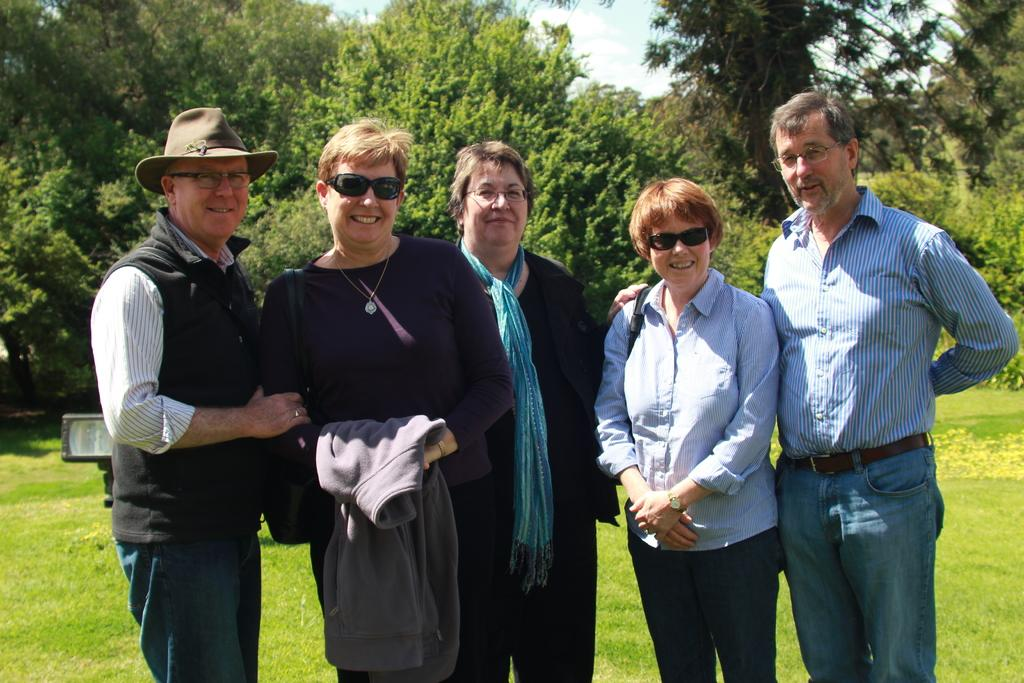What are the people in the image doing? The people in the image are standing on the ground. What can be seen in the background of the image? There are trees in the background of the image. What is visible in the sky in the image? The sky is visible in the image. Can you describe the object that resembles a light in the image? Yes, there is an object that looks like a light in the image. What type of chess move is being made by the people in the image? There is no chess game or move depicted in the image; the people are simply standing on the ground. 